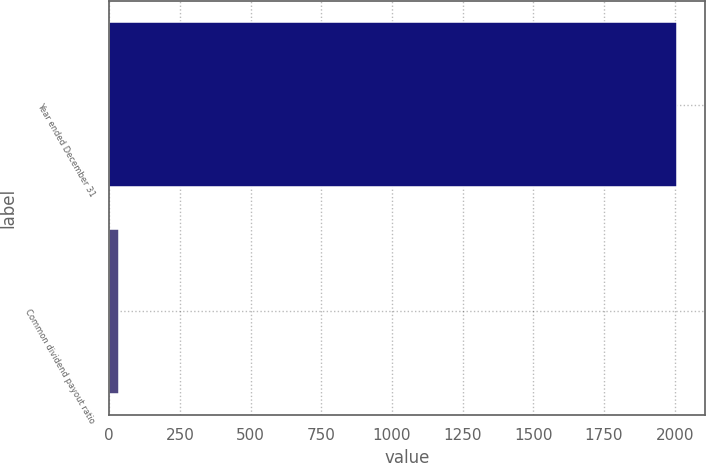Convert chart. <chart><loc_0><loc_0><loc_500><loc_500><bar_chart><fcel>Year ended December 31<fcel>Common dividend payout ratio<nl><fcel>2007<fcel>34<nl></chart> 